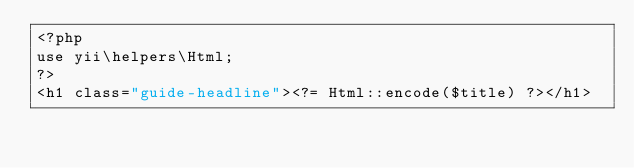<code> <loc_0><loc_0><loc_500><loc_500><_PHP_><?php
use yii\helpers\Html;
?>
<h1 class="guide-headline"><?= Html::encode($title) ?></h1>
</code> 